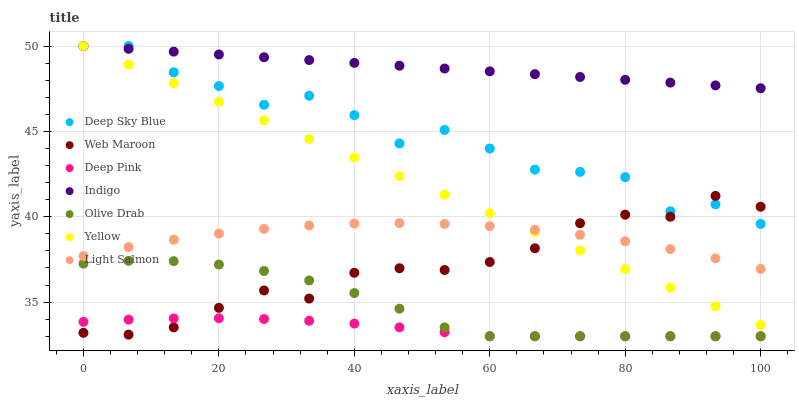Does Deep Pink have the minimum area under the curve?
Answer yes or no. Yes. Does Indigo have the maximum area under the curve?
Answer yes or no. Yes. Does Indigo have the minimum area under the curve?
Answer yes or no. No. Does Deep Pink have the maximum area under the curve?
Answer yes or no. No. Is Indigo the smoothest?
Answer yes or no. Yes. Is Deep Sky Blue the roughest?
Answer yes or no. Yes. Is Deep Pink the smoothest?
Answer yes or no. No. Is Deep Pink the roughest?
Answer yes or no. No. Does Deep Pink have the lowest value?
Answer yes or no. Yes. Does Indigo have the lowest value?
Answer yes or no. No. Does Deep Sky Blue have the highest value?
Answer yes or no. Yes. Does Deep Pink have the highest value?
Answer yes or no. No. Is Light Salmon less than Deep Sky Blue?
Answer yes or no. Yes. Is Indigo greater than Deep Pink?
Answer yes or no. Yes. Does Indigo intersect Yellow?
Answer yes or no. Yes. Is Indigo less than Yellow?
Answer yes or no. No. Is Indigo greater than Yellow?
Answer yes or no. No. Does Light Salmon intersect Deep Sky Blue?
Answer yes or no. No. 